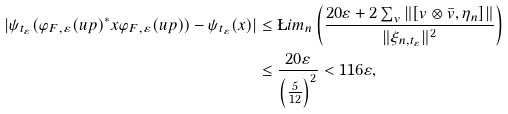Convert formula to latex. <formula><loc_0><loc_0><loc_500><loc_500>| \psi _ { t _ { \varepsilon } } ( \varphi _ { F , \varepsilon } ( u p ) ^ { * } x \varphi _ { F , \varepsilon } ( u p ) ) - \psi _ { t _ { \varepsilon } } ( x ) | & \leq \L i m _ { n } \left ( \frac { 2 0 \varepsilon + 2 \sum _ { v } \| [ v \otimes \bar { v } , \eta _ { n } ] \| } { \| \xi _ { n , t _ { \varepsilon } } \| ^ { 2 } } \right ) \\ & \leq \frac { 2 0 \varepsilon } { \left ( \frac { 5 } { 1 2 } \right ) ^ { 2 } } < 1 1 6 \varepsilon ,</formula> 